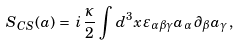Convert formula to latex. <formula><loc_0><loc_0><loc_500><loc_500>S _ { C S } ( a ) \, = \, i \, \frac { \kappa } { 2 } \, \int d ^ { 3 } x \, \varepsilon _ { \alpha \beta \gamma } a _ { \alpha } \, \partial _ { \beta } a _ { \gamma } \, ,</formula> 